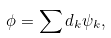Convert formula to latex. <formula><loc_0><loc_0><loc_500><loc_500>\phi = \sum d _ { k } \psi _ { k } ,</formula> 